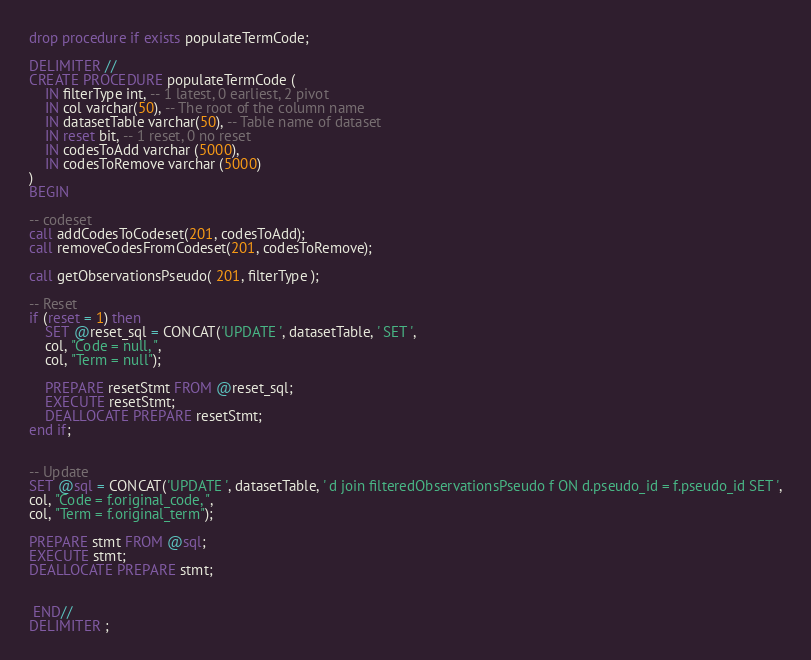<code> <loc_0><loc_0><loc_500><loc_500><_SQL_>drop procedure if exists populateTermCode;

DELIMITER //
CREATE PROCEDURE populateTermCode (
    IN filterType int, -- 1 latest, 0 earliest, 2 pivot
    IN col varchar(50), -- The root of the column name
    IN datasetTable varchar(50), -- Table name of dataset
    IN reset bit, -- 1 reset, 0 no reset
    IN codesToAdd varchar (5000),
    IN codesToRemove varchar (5000)
)
BEGIN

-- codeset
call addCodesToCodeset(201, codesToAdd);
call removeCodesFromCodeset(201, codesToRemove);

call getObservationsPseudo( 201, filterType );

-- Reset
if (reset = 1) then
	SET @reset_sql = CONCAT('UPDATE ', datasetTable, ' SET ',
	col, "Code = null, ",
	col, "Term = null");

	PREPARE resetStmt FROM @reset_sql;
	EXECUTE resetStmt;
	DEALLOCATE PREPARE resetStmt;
end if;


-- Update
SET @sql = CONCAT('UPDATE ', datasetTable, ' d join filteredObservationsPseudo f ON d.pseudo_id = f.pseudo_id SET ',
col, "Code = f.original_code, ",
col, "Term = f.original_term");

PREPARE stmt FROM @sql;
EXECUTE stmt;
DEALLOCATE PREPARE stmt;


 END//
DELIMITER ;
</code> 